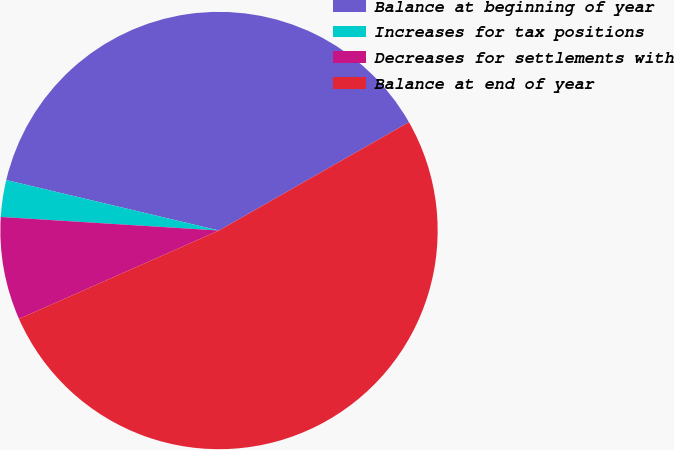Convert chart. <chart><loc_0><loc_0><loc_500><loc_500><pie_chart><fcel>Balance at beginning of year<fcel>Increases for tax positions<fcel>Decreases for settlements with<fcel>Balance at end of year<nl><fcel>38.04%<fcel>2.72%<fcel>7.61%<fcel>51.63%<nl></chart> 